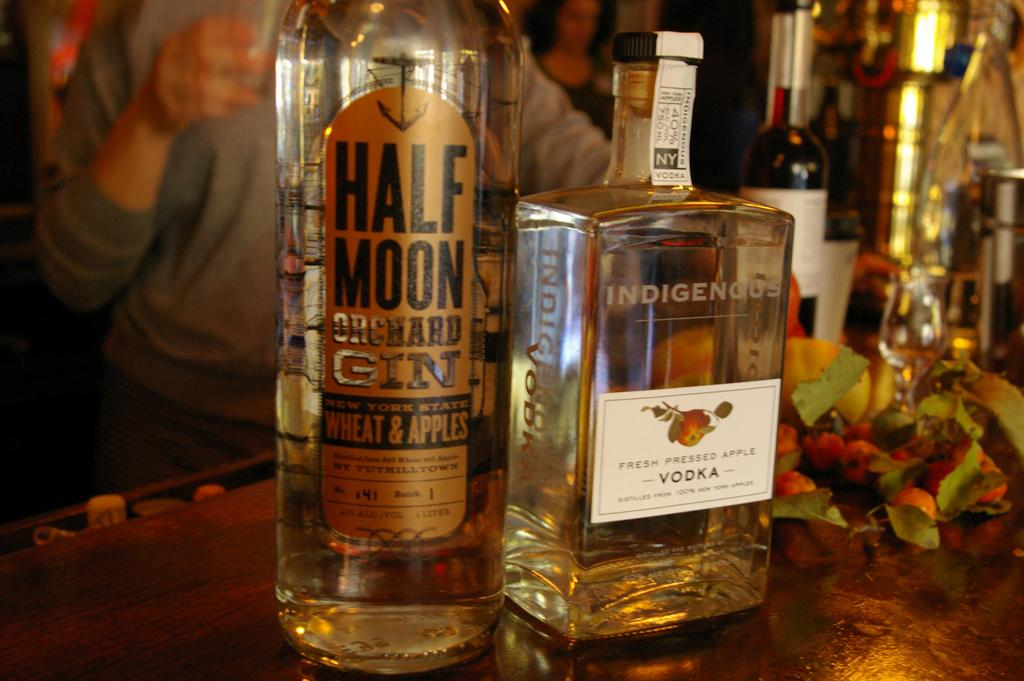Provide a one-sentence caption for the provided image. two bottles of liquor on a bar and one is called Half Moon Orchard Gin. 